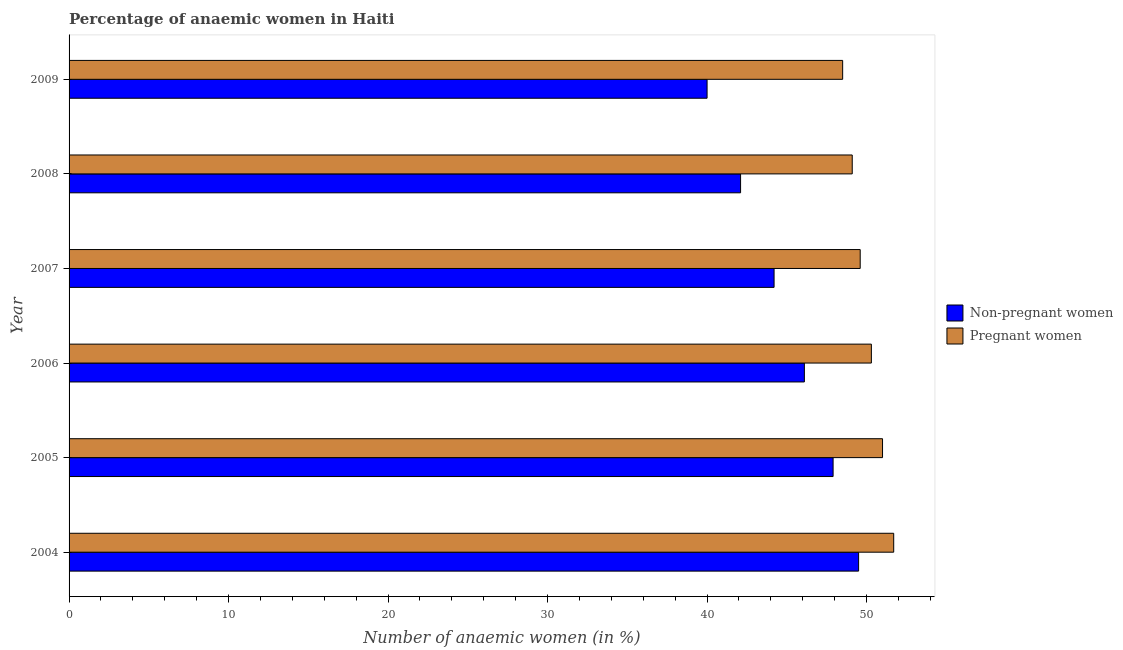How many different coloured bars are there?
Your response must be concise. 2. How many groups of bars are there?
Offer a very short reply. 6. How many bars are there on the 2nd tick from the bottom?
Provide a short and direct response. 2. What is the label of the 6th group of bars from the top?
Offer a very short reply. 2004. In how many cases, is the number of bars for a given year not equal to the number of legend labels?
Give a very brief answer. 0. Across all years, what is the maximum percentage of non-pregnant anaemic women?
Keep it short and to the point. 49.5. Across all years, what is the minimum percentage of pregnant anaemic women?
Offer a terse response. 48.5. In which year was the percentage of pregnant anaemic women minimum?
Your response must be concise. 2009. What is the total percentage of pregnant anaemic women in the graph?
Provide a short and direct response. 300.2. What is the difference between the percentage of non-pregnant anaemic women in 2009 and the percentage of pregnant anaemic women in 2005?
Your response must be concise. -11. What is the average percentage of non-pregnant anaemic women per year?
Provide a short and direct response. 44.97. In how many years, is the percentage of pregnant anaemic women greater than 36 %?
Provide a succinct answer. 6. What is the ratio of the percentage of non-pregnant anaemic women in 2004 to that in 2005?
Provide a short and direct response. 1.03. In how many years, is the percentage of non-pregnant anaemic women greater than the average percentage of non-pregnant anaemic women taken over all years?
Your answer should be compact. 3. Is the sum of the percentage of pregnant anaemic women in 2004 and 2008 greater than the maximum percentage of non-pregnant anaemic women across all years?
Your response must be concise. Yes. What does the 1st bar from the top in 2007 represents?
Make the answer very short. Pregnant women. What does the 2nd bar from the bottom in 2007 represents?
Keep it short and to the point. Pregnant women. How many bars are there?
Your answer should be very brief. 12. Are all the bars in the graph horizontal?
Your answer should be compact. Yes. Are the values on the major ticks of X-axis written in scientific E-notation?
Provide a succinct answer. No. Does the graph contain grids?
Your response must be concise. No. How are the legend labels stacked?
Offer a terse response. Vertical. What is the title of the graph?
Ensure brevity in your answer.  Percentage of anaemic women in Haiti. Does "Services" appear as one of the legend labels in the graph?
Your answer should be compact. No. What is the label or title of the X-axis?
Ensure brevity in your answer.  Number of anaemic women (in %). What is the label or title of the Y-axis?
Ensure brevity in your answer.  Year. What is the Number of anaemic women (in %) of Non-pregnant women in 2004?
Offer a terse response. 49.5. What is the Number of anaemic women (in %) in Pregnant women in 2004?
Offer a very short reply. 51.7. What is the Number of anaemic women (in %) of Non-pregnant women in 2005?
Ensure brevity in your answer.  47.9. What is the Number of anaemic women (in %) in Pregnant women in 2005?
Keep it short and to the point. 51. What is the Number of anaemic women (in %) in Non-pregnant women in 2006?
Give a very brief answer. 46.1. What is the Number of anaemic women (in %) of Pregnant women in 2006?
Keep it short and to the point. 50.3. What is the Number of anaemic women (in %) in Non-pregnant women in 2007?
Give a very brief answer. 44.2. What is the Number of anaemic women (in %) of Pregnant women in 2007?
Offer a very short reply. 49.6. What is the Number of anaemic women (in %) of Non-pregnant women in 2008?
Your response must be concise. 42.1. What is the Number of anaemic women (in %) of Pregnant women in 2008?
Provide a succinct answer. 49.1. What is the Number of anaemic women (in %) of Non-pregnant women in 2009?
Your answer should be very brief. 40. What is the Number of anaemic women (in %) in Pregnant women in 2009?
Ensure brevity in your answer.  48.5. Across all years, what is the maximum Number of anaemic women (in %) of Non-pregnant women?
Ensure brevity in your answer.  49.5. Across all years, what is the maximum Number of anaemic women (in %) in Pregnant women?
Ensure brevity in your answer.  51.7. Across all years, what is the minimum Number of anaemic women (in %) of Pregnant women?
Your answer should be very brief. 48.5. What is the total Number of anaemic women (in %) in Non-pregnant women in the graph?
Your response must be concise. 269.8. What is the total Number of anaemic women (in %) in Pregnant women in the graph?
Your answer should be compact. 300.2. What is the difference between the Number of anaemic women (in %) of Non-pregnant women in 2004 and that in 2005?
Offer a very short reply. 1.6. What is the difference between the Number of anaemic women (in %) of Pregnant women in 2004 and that in 2005?
Offer a terse response. 0.7. What is the difference between the Number of anaemic women (in %) in Pregnant women in 2004 and that in 2007?
Make the answer very short. 2.1. What is the difference between the Number of anaemic women (in %) of Non-pregnant women in 2004 and that in 2008?
Keep it short and to the point. 7.4. What is the difference between the Number of anaemic women (in %) in Pregnant women in 2004 and that in 2009?
Make the answer very short. 3.2. What is the difference between the Number of anaemic women (in %) in Non-pregnant women in 2005 and that in 2006?
Your answer should be compact. 1.8. What is the difference between the Number of anaemic women (in %) of Pregnant women in 2005 and that in 2006?
Provide a succinct answer. 0.7. What is the difference between the Number of anaemic women (in %) in Non-pregnant women in 2005 and that in 2007?
Your response must be concise. 3.7. What is the difference between the Number of anaemic women (in %) of Non-pregnant women in 2005 and that in 2008?
Your answer should be very brief. 5.8. What is the difference between the Number of anaemic women (in %) in Non-pregnant women in 2005 and that in 2009?
Your response must be concise. 7.9. What is the difference between the Number of anaemic women (in %) in Pregnant women in 2006 and that in 2007?
Ensure brevity in your answer.  0.7. What is the difference between the Number of anaemic women (in %) of Non-pregnant women in 2006 and that in 2008?
Your response must be concise. 4. What is the difference between the Number of anaemic women (in %) in Pregnant women in 2006 and that in 2008?
Your answer should be very brief. 1.2. What is the difference between the Number of anaemic women (in %) of Non-pregnant women in 2007 and that in 2009?
Make the answer very short. 4.2. What is the difference between the Number of anaemic women (in %) of Pregnant women in 2008 and that in 2009?
Your response must be concise. 0.6. What is the difference between the Number of anaemic women (in %) in Non-pregnant women in 2004 and the Number of anaemic women (in %) in Pregnant women in 2005?
Provide a short and direct response. -1.5. What is the difference between the Number of anaemic women (in %) of Non-pregnant women in 2004 and the Number of anaemic women (in %) of Pregnant women in 2006?
Your response must be concise. -0.8. What is the difference between the Number of anaemic women (in %) in Non-pregnant women in 2004 and the Number of anaemic women (in %) in Pregnant women in 2007?
Your answer should be compact. -0.1. What is the difference between the Number of anaemic women (in %) in Non-pregnant women in 2004 and the Number of anaemic women (in %) in Pregnant women in 2009?
Your answer should be very brief. 1. What is the difference between the Number of anaemic women (in %) in Non-pregnant women in 2005 and the Number of anaemic women (in %) in Pregnant women in 2008?
Your answer should be very brief. -1.2. What is the difference between the Number of anaemic women (in %) in Non-pregnant women in 2006 and the Number of anaemic women (in %) in Pregnant women in 2009?
Your response must be concise. -2.4. What is the difference between the Number of anaemic women (in %) of Non-pregnant women in 2007 and the Number of anaemic women (in %) of Pregnant women in 2009?
Your response must be concise. -4.3. What is the difference between the Number of anaemic women (in %) of Non-pregnant women in 2008 and the Number of anaemic women (in %) of Pregnant women in 2009?
Ensure brevity in your answer.  -6.4. What is the average Number of anaemic women (in %) in Non-pregnant women per year?
Your answer should be compact. 44.97. What is the average Number of anaemic women (in %) in Pregnant women per year?
Your answer should be very brief. 50.03. In the year 2005, what is the difference between the Number of anaemic women (in %) of Non-pregnant women and Number of anaemic women (in %) of Pregnant women?
Keep it short and to the point. -3.1. In the year 2006, what is the difference between the Number of anaemic women (in %) in Non-pregnant women and Number of anaemic women (in %) in Pregnant women?
Offer a very short reply. -4.2. In the year 2008, what is the difference between the Number of anaemic women (in %) in Non-pregnant women and Number of anaemic women (in %) in Pregnant women?
Your response must be concise. -7. In the year 2009, what is the difference between the Number of anaemic women (in %) in Non-pregnant women and Number of anaemic women (in %) in Pregnant women?
Ensure brevity in your answer.  -8.5. What is the ratio of the Number of anaemic women (in %) of Non-pregnant women in 2004 to that in 2005?
Provide a short and direct response. 1.03. What is the ratio of the Number of anaemic women (in %) in Pregnant women in 2004 to that in 2005?
Keep it short and to the point. 1.01. What is the ratio of the Number of anaemic women (in %) of Non-pregnant women in 2004 to that in 2006?
Ensure brevity in your answer.  1.07. What is the ratio of the Number of anaemic women (in %) of Pregnant women in 2004 to that in 2006?
Keep it short and to the point. 1.03. What is the ratio of the Number of anaemic women (in %) in Non-pregnant women in 2004 to that in 2007?
Offer a very short reply. 1.12. What is the ratio of the Number of anaemic women (in %) in Pregnant women in 2004 to that in 2007?
Offer a terse response. 1.04. What is the ratio of the Number of anaemic women (in %) in Non-pregnant women in 2004 to that in 2008?
Your answer should be compact. 1.18. What is the ratio of the Number of anaemic women (in %) of Pregnant women in 2004 to that in 2008?
Keep it short and to the point. 1.05. What is the ratio of the Number of anaemic women (in %) of Non-pregnant women in 2004 to that in 2009?
Offer a terse response. 1.24. What is the ratio of the Number of anaemic women (in %) in Pregnant women in 2004 to that in 2009?
Offer a terse response. 1.07. What is the ratio of the Number of anaemic women (in %) of Non-pregnant women in 2005 to that in 2006?
Keep it short and to the point. 1.04. What is the ratio of the Number of anaemic women (in %) of Pregnant women in 2005 to that in 2006?
Make the answer very short. 1.01. What is the ratio of the Number of anaemic women (in %) of Non-pregnant women in 2005 to that in 2007?
Your response must be concise. 1.08. What is the ratio of the Number of anaemic women (in %) of Pregnant women in 2005 to that in 2007?
Your answer should be compact. 1.03. What is the ratio of the Number of anaemic women (in %) of Non-pregnant women in 2005 to that in 2008?
Ensure brevity in your answer.  1.14. What is the ratio of the Number of anaemic women (in %) of Pregnant women in 2005 to that in 2008?
Offer a very short reply. 1.04. What is the ratio of the Number of anaemic women (in %) in Non-pregnant women in 2005 to that in 2009?
Provide a short and direct response. 1.2. What is the ratio of the Number of anaemic women (in %) in Pregnant women in 2005 to that in 2009?
Offer a terse response. 1.05. What is the ratio of the Number of anaemic women (in %) of Non-pregnant women in 2006 to that in 2007?
Your answer should be compact. 1.04. What is the ratio of the Number of anaemic women (in %) of Pregnant women in 2006 to that in 2007?
Make the answer very short. 1.01. What is the ratio of the Number of anaemic women (in %) in Non-pregnant women in 2006 to that in 2008?
Your response must be concise. 1.09. What is the ratio of the Number of anaemic women (in %) of Pregnant women in 2006 to that in 2008?
Make the answer very short. 1.02. What is the ratio of the Number of anaemic women (in %) in Non-pregnant women in 2006 to that in 2009?
Your answer should be compact. 1.15. What is the ratio of the Number of anaemic women (in %) of Pregnant women in 2006 to that in 2009?
Keep it short and to the point. 1.04. What is the ratio of the Number of anaemic women (in %) of Non-pregnant women in 2007 to that in 2008?
Keep it short and to the point. 1.05. What is the ratio of the Number of anaemic women (in %) in Pregnant women in 2007 to that in 2008?
Your response must be concise. 1.01. What is the ratio of the Number of anaemic women (in %) of Non-pregnant women in 2007 to that in 2009?
Keep it short and to the point. 1.1. What is the ratio of the Number of anaemic women (in %) in Pregnant women in 2007 to that in 2009?
Offer a terse response. 1.02. What is the ratio of the Number of anaemic women (in %) of Non-pregnant women in 2008 to that in 2009?
Provide a succinct answer. 1.05. What is the ratio of the Number of anaemic women (in %) of Pregnant women in 2008 to that in 2009?
Offer a terse response. 1.01. What is the difference between the highest and the lowest Number of anaemic women (in %) of Non-pregnant women?
Provide a succinct answer. 9.5. 